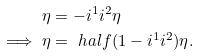<formula> <loc_0><loc_0><loc_500><loc_500>\eta & = - i ^ { 1 } i ^ { 2 } \eta \\ \implies \eta & = \ h a l f ( 1 - i ^ { 1 } i ^ { 2 } ) \eta .</formula> 